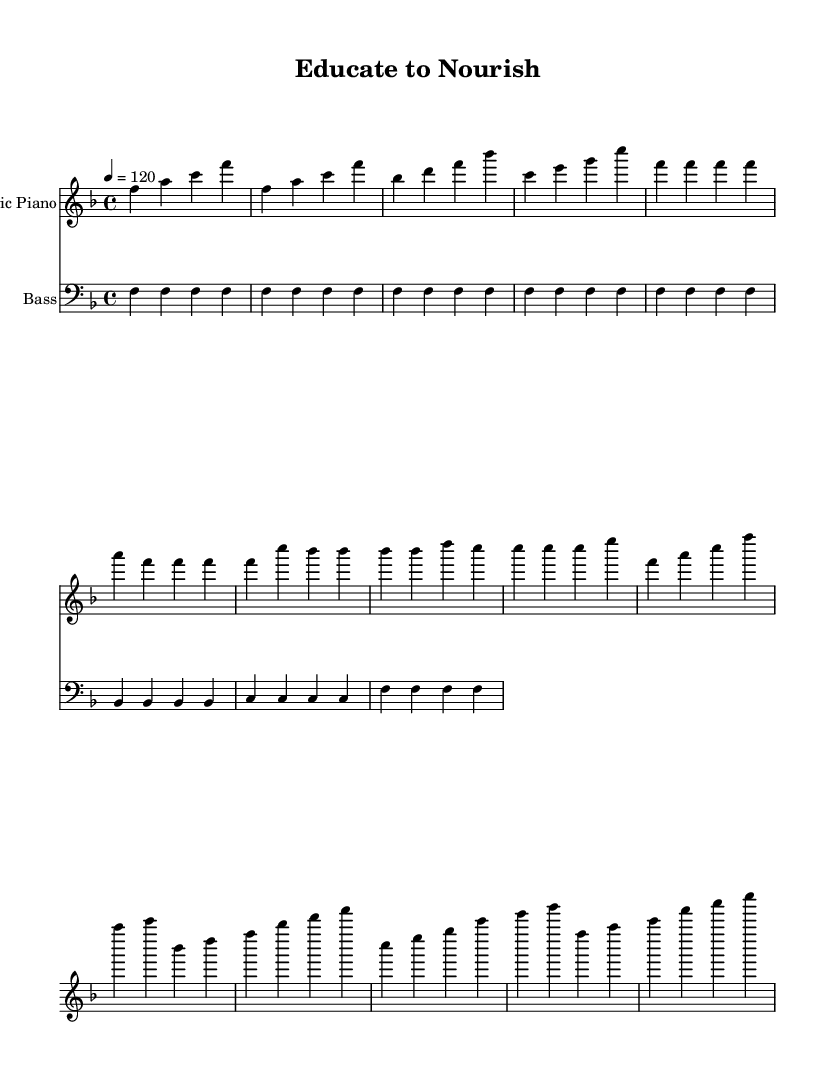What is the key signature of this music? The key signature shown at the beginning of the piece indicates F major, which has one flat (B♭).
Answer: F major What is the time signature of the piece? The time signature appears at the beginning and is 4/4, indicating four beats per measure.
Answer: 4/4 What is the tempo marking for this piece? The tempo marking specifies a speed of 120 beats per minute, indicating how fast the music should be played.
Answer: 120 How many measures are in the chorus? By examining the measures in the chorus section, there are four distinct measures present.
Answer: 4 What is the instrument used for the main melody? The main melody is played on the electric piano, which is indicated in the header of the staff.
Answer: Electric Piano How does the bass pattern change in the chorus? In the chorus, the bass pattern consists of four measures that repeat the notes, creating a consistent groove typical for disco music.
Answer: Repeats Is there a noticeable rhythmic structure unique to disco in this music? The 4/4 time signature and the frequent use of consistent, repetitive patterns create a danceable rhythm characteristic of disco music.
Answer: Yes 